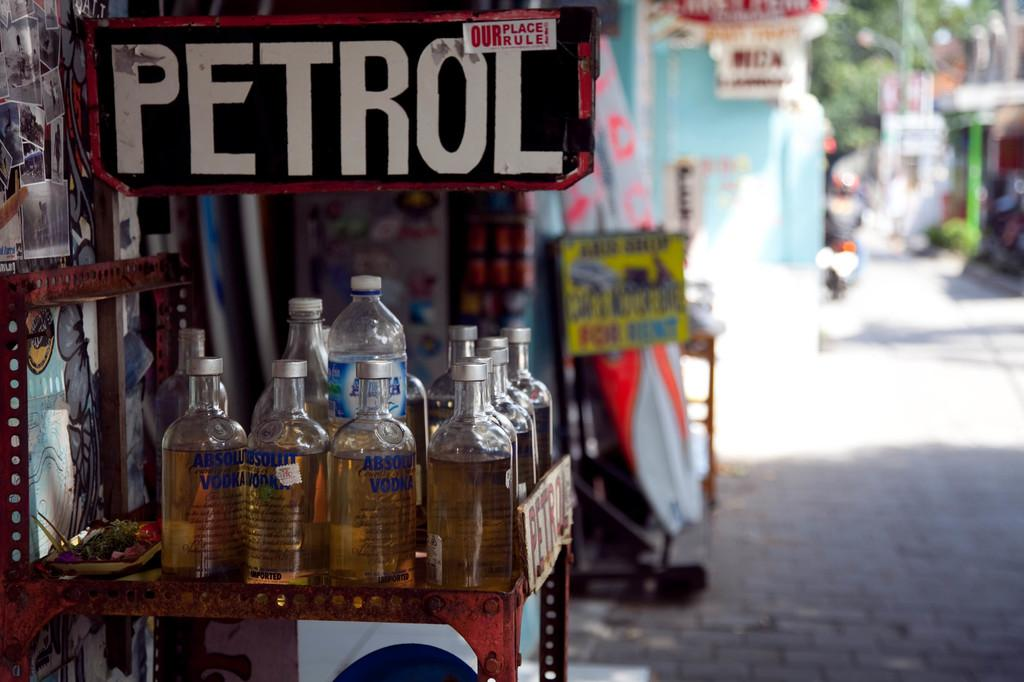<image>
Relay a brief, clear account of the picture shown. Petrol is advertised on the sign above the bottles. 